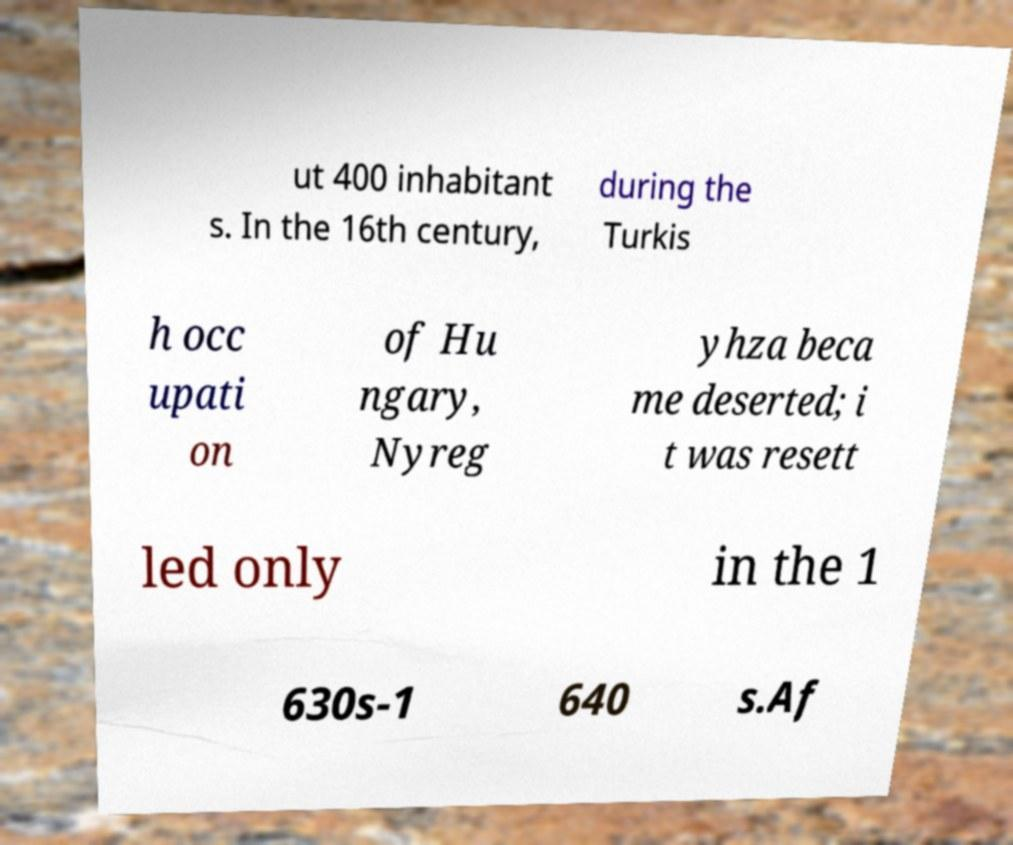I need the written content from this picture converted into text. Can you do that? ut 400 inhabitant s. In the 16th century, during the Turkis h occ upati on of Hu ngary, Nyreg yhza beca me deserted; i t was resett led only in the 1 630s-1 640 s.Af 